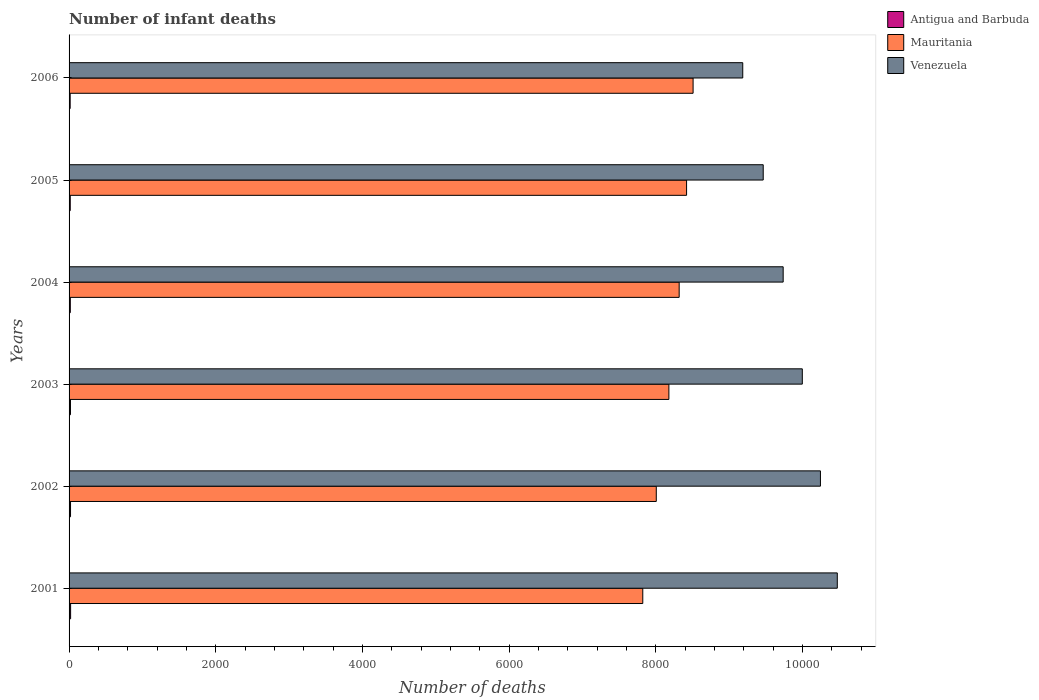How many different coloured bars are there?
Your answer should be very brief. 3. How many bars are there on the 1st tick from the bottom?
Provide a short and direct response. 3. Across all years, what is the maximum number of infant deaths in Antigua and Barbuda?
Keep it short and to the point. 21. Across all years, what is the minimum number of infant deaths in Mauritania?
Make the answer very short. 7822. In which year was the number of infant deaths in Venezuela maximum?
Ensure brevity in your answer.  2001. What is the total number of infant deaths in Venezuela in the graph?
Your answer should be compact. 5.91e+04. What is the difference between the number of infant deaths in Mauritania in 2004 and that in 2005?
Offer a terse response. -101. What is the difference between the number of infant deaths in Venezuela in 2004 and the number of infant deaths in Mauritania in 2002?
Offer a very short reply. 1730. What is the average number of infant deaths in Venezuela per year?
Your response must be concise. 9850. In the year 2002, what is the difference between the number of infant deaths in Mauritania and number of infant deaths in Venezuela?
Your answer should be very brief. -2238. What is the ratio of the number of infant deaths in Mauritania in 2002 to that in 2005?
Give a very brief answer. 0.95. What is the difference between the highest and the second highest number of infant deaths in Venezuela?
Give a very brief answer. 230. What is the difference between the highest and the lowest number of infant deaths in Venezuela?
Offer a terse response. 1289. What does the 3rd bar from the top in 2002 represents?
Provide a succinct answer. Antigua and Barbuda. What does the 3rd bar from the bottom in 2002 represents?
Provide a succinct answer. Venezuela. How many bars are there?
Offer a very short reply. 18. Are all the bars in the graph horizontal?
Your response must be concise. Yes. Are the values on the major ticks of X-axis written in scientific E-notation?
Ensure brevity in your answer.  No. Does the graph contain any zero values?
Offer a terse response. No. Does the graph contain grids?
Your answer should be very brief. No. Where does the legend appear in the graph?
Make the answer very short. Top right. How many legend labels are there?
Provide a short and direct response. 3. What is the title of the graph?
Your response must be concise. Number of infant deaths. Does "Europe(all income levels)" appear as one of the legend labels in the graph?
Provide a short and direct response. No. What is the label or title of the X-axis?
Offer a terse response. Number of deaths. What is the label or title of the Y-axis?
Make the answer very short. Years. What is the Number of deaths in Mauritania in 2001?
Provide a succinct answer. 7822. What is the Number of deaths in Venezuela in 2001?
Make the answer very short. 1.05e+04. What is the Number of deaths of Antigua and Barbuda in 2002?
Your answer should be compact. 20. What is the Number of deaths of Mauritania in 2002?
Give a very brief answer. 8006. What is the Number of deaths of Venezuela in 2002?
Make the answer very short. 1.02e+04. What is the Number of deaths in Mauritania in 2003?
Make the answer very short. 8178. What is the Number of deaths in Venezuela in 2003?
Your answer should be very brief. 9997. What is the Number of deaths in Antigua and Barbuda in 2004?
Provide a short and direct response. 17. What is the Number of deaths in Mauritania in 2004?
Provide a short and direct response. 8318. What is the Number of deaths in Venezuela in 2004?
Offer a terse response. 9736. What is the Number of deaths in Antigua and Barbuda in 2005?
Offer a terse response. 16. What is the Number of deaths of Mauritania in 2005?
Offer a very short reply. 8419. What is the Number of deaths of Venezuela in 2005?
Ensure brevity in your answer.  9464. What is the Number of deaths in Mauritania in 2006?
Ensure brevity in your answer.  8508. What is the Number of deaths of Venezuela in 2006?
Provide a succinct answer. 9185. Across all years, what is the maximum Number of deaths in Antigua and Barbuda?
Your response must be concise. 21. Across all years, what is the maximum Number of deaths in Mauritania?
Provide a succinct answer. 8508. Across all years, what is the maximum Number of deaths in Venezuela?
Your answer should be very brief. 1.05e+04. Across all years, what is the minimum Number of deaths in Mauritania?
Give a very brief answer. 7822. Across all years, what is the minimum Number of deaths in Venezuela?
Your response must be concise. 9185. What is the total Number of deaths of Antigua and Barbuda in the graph?
Your answer should be compact. 108. What is the total Number of deaths of Mauritania in the graph?
Provide a succinct answer. 4.93e+04. What is the total Number of deaths in Venezuela in the graph?
Offer a very short reply. 5.91e+04. What is the difference between the Number of deaths in Antigua and Barbuda in 2001 and that in 2002?
Give a very brief answer. 1. What is the difference between the Number of deaths in Mauritania in 2001 and that in 2002?
Offer a terse response. -184. What is the difference between the Number of deaths in Venezuela in 2001 and that in 2002?
Provide a short and direct response. 230. What is the difference between the Number of deaths in Antigua and Barbuda in 2001 and that in 2003?
Offer a very short reply. 2. What is the difference between the Number of deaths of Mauritania in 2001 and that in 2003?
Keep it short and to the point. -356. What is the difference between the Number of deaths in Venezuela in 2001 and that in 2003?
Ensure brevity in your answer.  477. What is the difference between the Number of deaths in Mauritania in 2001 and that in 2004?
Keep it short and to the point. -496. What is the difference between the Number of deaths of Venezuela in 2001 and that in 2004?
Give a very brief answer. 738. What is the difference between the Number of deaths in Antigua and Barbuda in 2001 and that in 2005?
Give a very brief answer. 5. What is the difference between the Number of deaths in Mauritania in 2001 and that in 2005?
Provide a succinct answer. -597. What is the difference between the Number of deaths in Venezuela in 2001 and that in 2005?
Make the answer very short. 1010. What is the difference between the Number of deaths of Mauritania in 2001 and that in 2006?
Provide a succinct answer. -686. What is the difference between the Number of deaths in Venezuela in 2001 and that in 2006?
Keep it short and to the point. 1289. What is the difference between the Number of deaths in Mauritania in 2002 and that in 2003?
Ensure brevity in your answer.  -172. What is the difference between the Number of deaths of Venezuela in 2002 and that in 2003?
Give a very brief answer. 247. What is the difference between the Number of deaths in Antigua and Barbuda in 2002 and that in 2004?
Offer a terse response. 3. What is the difference between the Number of deaths in Mauritania in 2002 and that in 2004?
Offer a terse response. -312. What is the difference between the Number of deaths of Venezuela in 2002 and that in 2004?
Provide a short and direct response. 508. What is the difference between the Number of deaths in Antigua and Barbuda in 2002 and that in 2005?
Provide a short and direct response. 4. What is the difference between the Number of deaths in Mauritania in 2002 and that in 2005?
Make the answer very short. -413. What is the difference between the Number of deaths of Venezuela in 2002 and that in 2005?
Give a very brief answer. 780. What is the difference between the Number of deaths of Mauritania in 2002 and that in 2006?
Give a very brief answer. -502. What is the difference between the Number of deaths in Venezuela in 2002 and that in 2006?
Your response must be concise. 1059. What is the difference between the Number of deaths in Mauritania in 2003 and that in 2004?
Offer a very short reply. -140. What is the difference between the Number of deaths in Venezuela in 2003 and that in 2004?
Offer a terse response. 261. What is the difference between the Number of deaths of Mauritania in 2003 and that in 2005?
Provide a succinct answer. -241. What is the difference between the Number of deaths in Venezuela in 2003 and that in 2005?
Ensure brevity in your answer.  533. What is the difference between the Number of deaths of Mauritania in 2003 and that in 2006?
Make the answer very short. -330. What is the difference between the Number of deaths in Venezuela in 2003 and that in 2006?
Ensure brevity in your answer.  812. What is the difference between the Number of deaths in Antigua and Barbuda in 2004 and that in 2005?
Offer a very short reply. 1. What is the difference between the Number of deaths of Mauritania in 2004 and that in 2005?
Your answer should be very brief. -101. What is the difference between the Number of deaths in Venezuela in 2004 and that in 2005?
Your response must be concise. 272. What is the difference between the Number of deaths in Mauritania in 2004 and that in 2006?
Offer a terse response. -190. What is the difference between the Number of deaths of Venezuela in 2004 and that in 2006?
Offer a terse response. 551. What is the difference between the Number of deaths in Antigua and Barbuda in 2005 and that in 2006?
Offer a terse response. 1. What is the difference between the Number of deaths of Mauritania in 2005 and that in 2006?
Your answer should be compact. -89. What is the difference between the Number of deaths in Venezuela in 2005 and that in 2006?
Offer a terse response. 279. What is the difference between the Number of deaths in Antigua and Barbuda in 2001 and the Number of deaths in Mauritania in 2002?
Your response must be concise. -7985. What is the difference between the Number of deaths of Antigua and Barbuda in 2001 and the Number of deaths of Venezuela in 2002?
Provide a short and direct response. -1.02e+04. What is the difference between the Number of deaths in Mauritania in 2001 and the Number of deaths in Venezuela in 2002?
Provide a succinct answer. -2422. What is the difference between the Number of deaths in Antigua and Barbuda in 2001 and the Number of deaths in Mauritania in 2003?
Offer a terse response. -8157. What is the difference between the Number of deaths in Antigua and Barbuda in 2001 and the Number of deaths in Venezuela in 2003?
Give a very brief answer. -9976. What is the difference between the Number of deaths of Mauritania in 2001 and the Number of deaths of Venezuela in 2003?
Your response must be concise. -2175. What is the difference between the Number of deaths of Antigua and Barbuda in 2001 and the Number of deaths of Mauritania in 2004?
Ensure brevity in your answer.  -8297. What is the difference between the Number of deaths in Antigua and Barbuda in 2001 and the Number of deaths in Venezuela in 2004?
Offer a terse response. -9715. What is the difference between the Number of deaths in Mauritania in 2001 and the Number of deaths in Venezuela in 2004?
Keep it short and to the point. -1914. What is the difference between the Number of deaths of Antigua and Barbuda in 2001 and the Number of deaths of Mauritania in 2005?
Offer a very short reply. -8398. What is the difference between the Number of deaths of Antigua and Barbuda in 2001 and the Number of deaths of Venezuela in 2005?
Keep it short and to the point. -9443. What is the difference between the Number of deaths in Mauritania in 2001 and the Number of deaths in Venezuela in 2005?
Provide a succinct answer. -1642. What is the difference between the Number of deaths in Antigua and Barbuda in 2001 and the Number of deaths in Mauritania in 2006?
Offer a terse response. -8487. What is the difference between the Number of deaths of Antigua and Barbuda in 2001 and the Number of deaths of Venezuela in 2006?
Offer a very short reply. -9164. What is the difference between the Number of deaths in Mauritania in 2001 and the Number of deaths in Venezuela in 2006?
Ensure brevity in your answer.  -1363. What is the difference between the Number of deaths in Antigua and Barbuda in 2002 and the Number of deaths in Mauritania in 2003?
Your answer should be compact. -8158. What is the difference between the Number of deaths of Antigua and Barbuda in 2002 and the Number of deaths of Venezuela in 2003?
Your response must be concise. -9977. What is the difference between the Number of deaths of Mauritania in 2002 and the Number of deaths of Venezuela in 2003?
Provide a succinct answer. -1991. What is the difference between the Number of deaths in Antigua and Barbuda in 2002 and the Number of deaths in Mauritania in 2004?
Make the answer very short. -8298. What is the difference between the Number of deaths of Antigua and Barbuda in 2002 and the Number of deaths of Venezuela in 2004?
Your response must be concise. -9716. What is the difference between the Number of deaths in Mauritania in 2002 and the Number of deaths in Venezuela in 2004?
Make the answer very short. -1730. What is the difference between the Number of deaths in Antigua and Barbuda in 2002 and the Number of deaths in Mauritania in 2005?
Give a very brief answer. -8399. What is the difference between the Number of deaths in Antigua and Barbuda in 2002 and the Number of deaths in Venezuela in 2005?
Ensure brevity in your answer.  -9444. What is the difference between the Number of deaths of Mauritania in 2002 and the Number of deaths of Venezuela in 2005?
Provide a short and direct response. -1458. What is the difference between the Number of deaths of Antigua and Barbuda in 2002 and the Number of deaths of Mauritania in 2006?
Offer a terse response. -8488. What is the difference between the Number of deaths of Antigua and Barbuda in 2002 and the Number of deaths of Venezuela in 2006?
Provide a succinct answer. -9165. What is the difference between the Number of deaths in Mauritania in 2002 and the Number of deaths in Venezuela in 2006?
Your answer should be very brief. -1179. What is the difference between the Number of deaths in Antigua and Barbuda in 2003 and the Number of deaths in Mauritania in 2004?
Offer a terse response. -8299. What is the difference between the Number of deaths in Antigua and Barbuda in 2003 and the Number of deaths in Venezuela in 2004?
Offer a very short reply. -9717. What is the difference between the Number of deaths in Mauritania in 2003 and the Number of deaths in Venezuela in 2004?
Make the answer very short. -1558. What is the difference between the Number of deaths of Antigua and Barbuda in 2003 and the Number of deaths of Mauritania in 2005?
Give a very brief answer. -8400. What is the difference between the Number of deaths of Antigua and Barbuda in 2003 and the Number of deaths of Venezuela in 2005?
Give a very brief answer. -9445. What is the difference between the Number of deaths in Mauritania in 2003 and the Number of deaths in Venezuela in 2005?
Offer a very short reply. -1286. What is the difference between the Number of deaths in Antigua and Barbuda in 2003 and the Number of deaths in Mauritania in 2006?
Your answer should be very brief. -8489. What is the difference between the Number of deaths in Antigua and Barbuda in 2003 and the Number of deaths in Venezuela in 2006?
Give a very brief answer. -9166. What is the difference between the Number of deaths of Mauritania in 2003 and the Number of deaths of Venezuela in 2006?
Give a very brief answer. -1007. What is the difference between the Number of deaths in Antigua and Barbuda in 2004 and the Number of deaths in Mauritania in 2005?
Make the answer very short. -8402. What is the difference between the Number of deaths of Antigua and Barbuda in 2004 and the Number of deaths of Venezuela in 2005?
Your answer should be very brief. -9447. What is the difference between the Number of deaths of Mauritania in 2004 and the Number of deaths of Venezuela in 2005?
Ensure brevity in your answer.  -1146. What is the difference between the Number of deaths of Antigua and Barbuda in 2004 and the Number of deaths of Mauritania in 2006?
Keep it short and to the point. -8491. What is the difference between the Number of deaths in Antigua and Barbuda in 2004 and the Number of deaths in Venezuela in 2006?
Your answer should be compact. -9168. What is the difference between the Number of deaths of Mauritania in 2004 and the Number of deaths of Venezuela in 2006?
Ensure brevity in your answer.  -867. What is the difference between the Number of deaths of Antigua and Barbuda in 2005 and the Number of deaths of Mauritania in 2006?
Offer a terse response. -8492. What is the difference between the Number of deaths of Antigua and Barbuda in 2005 and the Number of deaths of Venezuela in 2006?
Provide a succinct answer. -9169. What is the difference between the Number of deaths of Mauritania in 2005 and the Number of deaths of Venezuela in 2006?
Make the answer very short. -766. What is the average Number of deaths in Antigua and Barbuda per year?
Offer a terse response. 18. What is the average Number of deaths in Mauritania per year?
Offer a very short reply. 8208.5. What is the average Number of deaths in Venezuela per year?
Your answer should be compact. 9850. In the year 2001, what is the difference between the Number of deaths in Antigua and Barbuda and Number of deaths in Mauritania?
Provide a succinct answer. -7801. In the year 2001, what is the difference between the Number of deaths of Antigua and Barbuda and Number of deaths of Venezuela?
Provide a short and direct response. -1.05e+04. In the year 2001, what is the difference between the Number of deaths of Mauritania and Number of deaths of Venezuela?
Give a very brief answer. -2652. In the year 2002, what is the difference between the Number of deaths of Antigua and Barbuda and Number of deaths of Mauritania?
Provide a short and direct response. -7986. In the year 2002, what is the difference between the Number of deaths of Antigua and Barbuda and Number of deaths of Venezuela?
Your answer should be compact. -1.02e+04. In the year 2002, what is the difference between the Number of deaths in Mauritania and Number of deaths in Venezuela?
Your answer should be compact. -2238. In the year 2003, what is the difference between the Number of deaths in Antigua and Barbuda and Number of deaths in Mauritania?
Ensure brevity in your answer.  -8159. In the year 2003, what is the difference between the Number of deaths in Antigua and Barbuda and Number of deaths in Venezuela?
Your answer should be compact. -9978. In the year 2003, what is the difference between the Number of deaths in Mauritania and Number of deaths in Venezuela?
Provide a succinct answer. -1819. In the year 2004, what is the difference between the Number of deaths of Antigua and Barbuda and Number of deaths of Mauritania?
Your answer should be very brief. -8301. In the year 2004, what is the difference between the Number of deaths of Antigua and Barbuda and Number of deaths of Venezuela?
Your answer should be very brief. -9719. In the year 2004, what is the difference between the Number of deaths in Mauritania and Number of deaths in Venezuela?
Provide a succinct answer. -1418. In the year 2005, what is the difference between the Number of deaths of Antigua and Barbuda and Number of deaths of Mauritania?
Give a very brief answer. -8403. In the year 2005, what is the difference between the Number of deaths of Antigua and Barbuda and Number of deaths of Venezuela?
Your answer should be compact. -9448. In the year 2005, what is the difference between the Number of deaths of Mauritania and Number of deaths of Venezuela?
Make the answer very short. -1045. In the year 2006, what is the difference between the Number of deaths in Antigua and Barbuda and Number of deaths in Mauritania?
Provide a succinct answer. -8493. In the year 2006, what is the difference between the Number of deaths of Antigua and Barbuda and Number of deaths of Venezuela?
Your answer should be very brief. -9170. In the year 2006, what is the difference between the Number of deaths in Mauritania and Number of deaths in Venezuela?
Make the answer very short. -677. What is the ratio of the Number of deaths of Mauritania in 2001 to that in 2002?
Ensure brevity in your answer.  0.98. What is the ratio of the Number of deaths in Venezuela in 2001 to that in 2002?
Provide a short and direct response. 1.02. What is the ratio of the Number of deaths of Antigua and Barbuda in 2001 to that in 2003?
Offer a terse response. 1.11. What is the ratio of the Number of deaths of Mauritania in 2001 to that in 2003?
Provide a succinct answer. 0.96. What is the ratio of the Number of deaths in Venezuela in 2001 to that in 2003?
Ensure brevity in your answer.  1.05. What is the ratio of the Number of deaths in Antigua and Barbuda in 2001 to that in 2004?
Offer a very short reply. 1.24. What is the ratio of the Number of deaths in Mauritania in 2001 to that in 2004?
Ensure brevity in your answer.  0.94. What is the ratio of the Number of deaths of Venezuela in 2001 to that in 2004?
Offer a terse response. 1.08. What is the ratio of the Number of deaths of Antigua and Barbuda in 2001 to that in 2005?
Offer a terse response. 1.31. What is the ratio of the Number of deaths in Mauritania in 2001 to that in 2005?
Offer a very short reply. 0.93. What is the ratio of the Number of deaths in Venezuela in 2001 to that in 2005?
Offer a terse response. 1.11. What is the ratio of the Number of deaths in Antigua and Barbuda in 2001 to that in 2006?
Offer a terse response. 1.4. What is the ratio of the Number of deaths of Mauritania in 2001 to that in 2006?
Ensure brevity in your answer.  0.92. What is the ratio of the Number of deaths in Venezuela in 2001 to that in 2006?
Give a very brief answer. 1.14. What is the ratio of the Number of deaths in Antigua and Barbuda in 2002 to that in 2003?
Make the answer very short. 1.05. What is the ratio of the Number of deaths in Venezuela in 2002 to that in 2003?
Keep it short and to the point. 1.02. What is the ratio of the Number of deaths in Antigua and Barbuda in 2002 to that in 2004?
Make the answer very short. 1.18. What is the ratio of the Number of deaths in Mauritania in 2002 to that in 2004?
Ensure brevity in your answer.  0.96. What is the ratio of the Number of deaths of Venezuela in 2002 to that in 2004?
Your response must be concise. 1.05. What is the ratio of the Number of deaths of Mauritania in 2002 to that in 2005?
Provide a succinct answer. 0.95. What is the ratio of the Number of deaths in Venezuela in 2002 to that in 2005?
Your response must be concise. 1.08. What is the ratio of the Number of deaths in Antigua and Barbuda in 2002 to that in 2006?
Ensure brevity in your answer.  1.33. What is the ratio of the Number of deaths in Mauritania in 2002 to that in 2006?
Offer a very short reply. 0.94. What is the ratio of the Number of deaths in Venezuela in 2002 to that in 2006?
Your answer should be compact. 1.12. What is the ratio of the Number of deaths in Antigua and Barbuda in 2003 to that in 2004?
Ensure brevity in your answer.  1.12. What is the ratio of the Number of deaths in Mauritania in 2003 to that in 2004?
Offer a very short reply. 0.98. What is the ratio of the Number of deaths in Venezuela in 2003 to that in 2004?
Provide a short and direct response. 1.03. What is the ratio of the Number of deaths of Antigua and Barbuda in 2003 to that in 2005?
Your answer should be very brief. 1.19. What is the ratio of the Number of deaths of Mauritania in 2003 to that in 2005?
Keep it short and to the point. 0.97. What is the ratio of the Number of deaths of Venezuela in 2003 to that in 2005?
Your response must be concise. 1.06. What is the ratio of the Number of deaths in Antigua and Barbuda in 2003 to that in 2006?
Provide a short and direct response. 1.27. What is the ratio of the Number of deaths of Mauritania in 2003 to that in 2006?
Ensure brevity in your answer.  0.96. What is the ratio of the Number of deaths in Venezuela in 2003 to that in 2006?
Offer a very short reply. 1.09. What is the ratio of the Number of deaths of Venezuela in 2004 to that in 2005?
Offer a terse response. 1.03. What is the ratio of the Number of deaths of Antigua and Barbuda in 2004 to that in 2006?
Provide a short and direct response. 1.13. What is the ratio of the Number of deaths of Mauritania in 2004 to that in 2006?
Provide a short and direct response. 0.98. What is the ratio of the Number of deaths in Venezuela in 2004 to that in 2006?
Your answer should be very brief. 1.06. What is the ratio of the Number of deaths in Antigua and Barbuda in 2005 to that in 2006?
Keep it short and to the point. 1.07. What is the ratio of the Number of deaths in Mauritania in 2005 to that in 2006?
Your answer should be compact. 0.99. What is the ratio of the Number of deaths in Venezuela in 2005 to that in 2006?
Provide a succinct answer. 1.03. What is the difference between the highest and the second highest Number of deaths in Mauritania?
Your answer should be very brief. 89. What is the difference between the highest and the second highest Number of deaths of Venezuela?
Provide a short and direct response. 230. What is the difference between the highest and the lowest Number of deaths of Antigua and Barbuda?
Offer a very short reply. 6. What is the difference between the highest and the lowest Number of deaths in Mauritania?
Offer a very short reply. 686. What is the difference between the highest and the lowest Number of deaths of Venezuela?
Your answer should be very brief. 1289. 